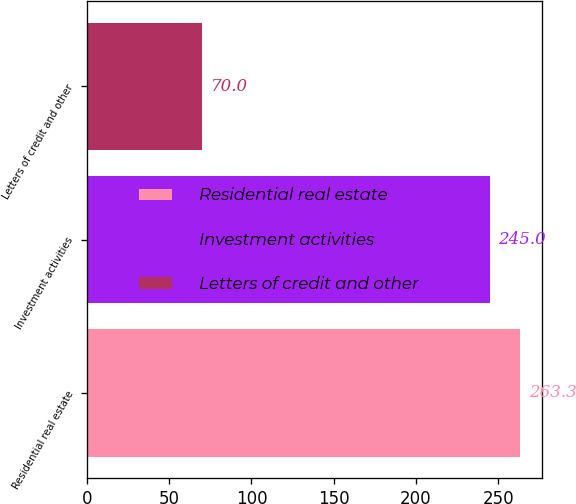<chart> <loc_0><loc_0><loc_500><loc_500><bar_chart><fcel>Residential real estate<fcel>Investment activities<fcel>Letters of credit and other<nl><fcel>263.3<fcel>245<fcel>70<nl></chart> 